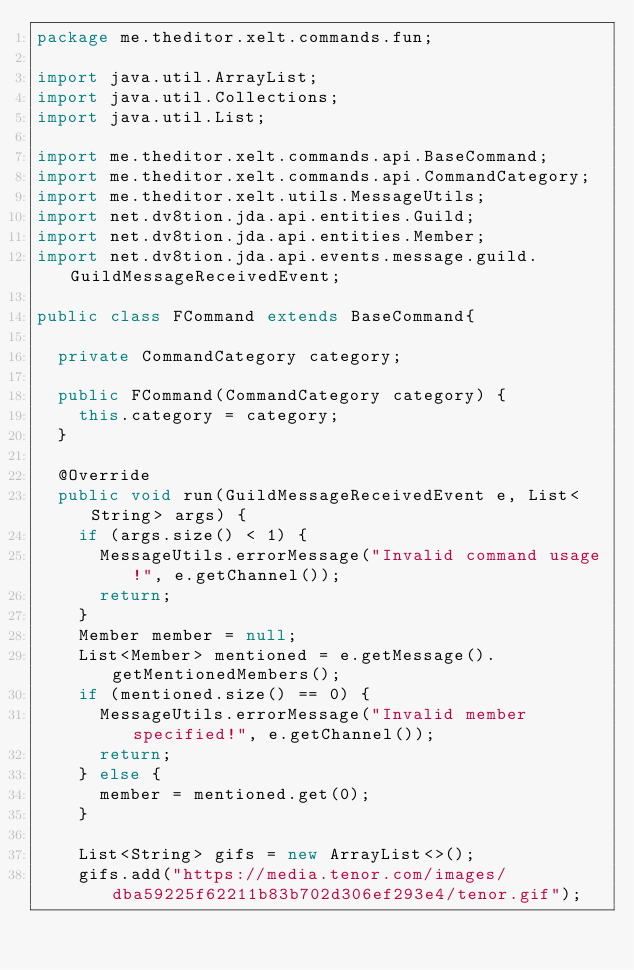<code> <loc_0><loc_0><loc_500><loc_500><_Java_>package me.theditor.xelt.commands.fun;

import java.util.ArrayList;
import java.util.Collections;
import java.util.List;

import me.theditor.xelt.commands.api.BaseCommand;
import me.theditor.xelt.commands.api.CommandCategory;
import me.theditor.xelt.utils.MessageUtils;
import net.dv8tion.jda.api.entities.Guild;
import net.dv8tion.jda.api.entities.Member;
import net.dv8tion.jda.api.events.message.guild.GuildMessageReceivedEvent;

public class FCommand extends BaseCommand{
	
	private CommandCategory category;

	public FCommand(CommandCategory category) {
		this.category = category;
	}

	@Override
	public void run(GuildMessageReceivedEvent e, List<String> args) {
		if (args.size() < 1) {
			MessageUtils.errorMessage("Invalid command usage!", e.getChannel());
			return;
		}
		Member member = null;
		List<Member> mentioned = e.getMessage().getMentionedMembers();
		if (mentioned.size() == 0) {
			MessageUtils.errorMessage("Invalid member specified!", e.getChannel());
			return;
		} else {
			member = mentioned.get(0);
		}
		
		List<String> gifs = new ArrayList<>();
		gifs.add("https://media.tenor.com/images/dba59225f62211b83b702d306ef293e4/tenor.gif");</code> 